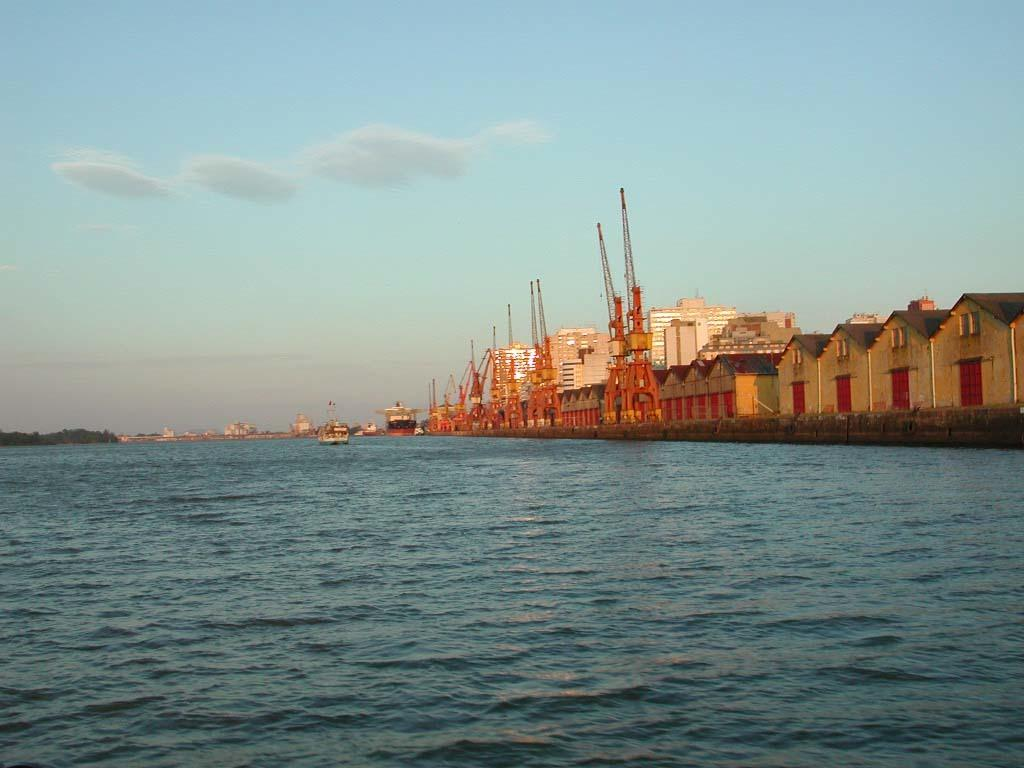What natural feature is present in the image? The image contains the sea. What type of structures can be seen in the image? There are houses, buildings, and towers in the image. What type of vegetation is present in the image? There are trees in the image. What mode of transportation is visible in the image? There is a boat in the image. What part of the natural environment is visible in the background of the image? The sky is visible in the background of the image. What type of payment is being made in the image? There is no indication of any payment being made in the image. What is the person in the image offering to the viewer? There is no person visible in the image, so it is not possible to determine what they might be offering. 